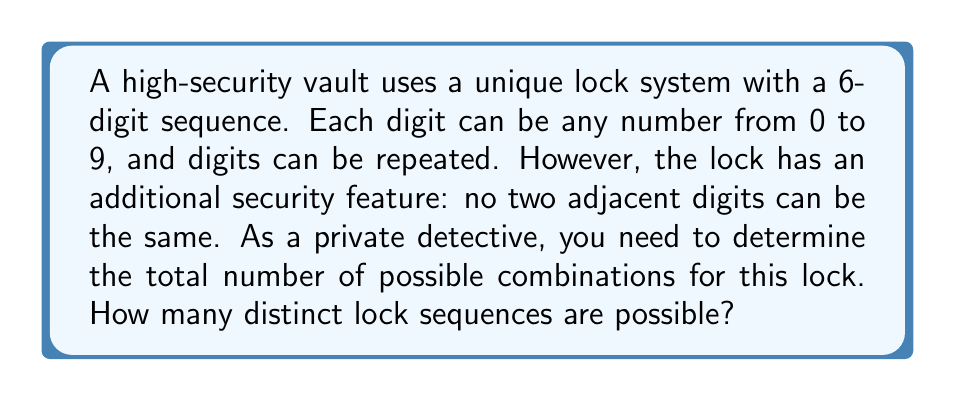Solve this math problem. Let's approach this step-by-step:

1) For the first digit, we have 10 choices (0-9).

2) For each subsequent digit, we have 9 choices, as it can't be the same as the previous digit.

3) We can represent this as a multiplication:
   $$ 10 \cdot 9 \cdot 9 \cdot 9 \cdot 9 \cdot 9 $$

4) This is because:
   - We have 10 choices for the 1st digit
   - 9 choices each for the 2nd, 3rd, 4th, 5th, and 6th digits

5) We can simplify this expression:
   $$ 10 \cdot 9^5 $$

6) Let's calculate:
   $$ 10 \cdot 9^5 = 10 \cdot 59049 = 590490 $$

Therefore, there are 590,490 possible combinations for this lock sequence.
Answer: 590,490 